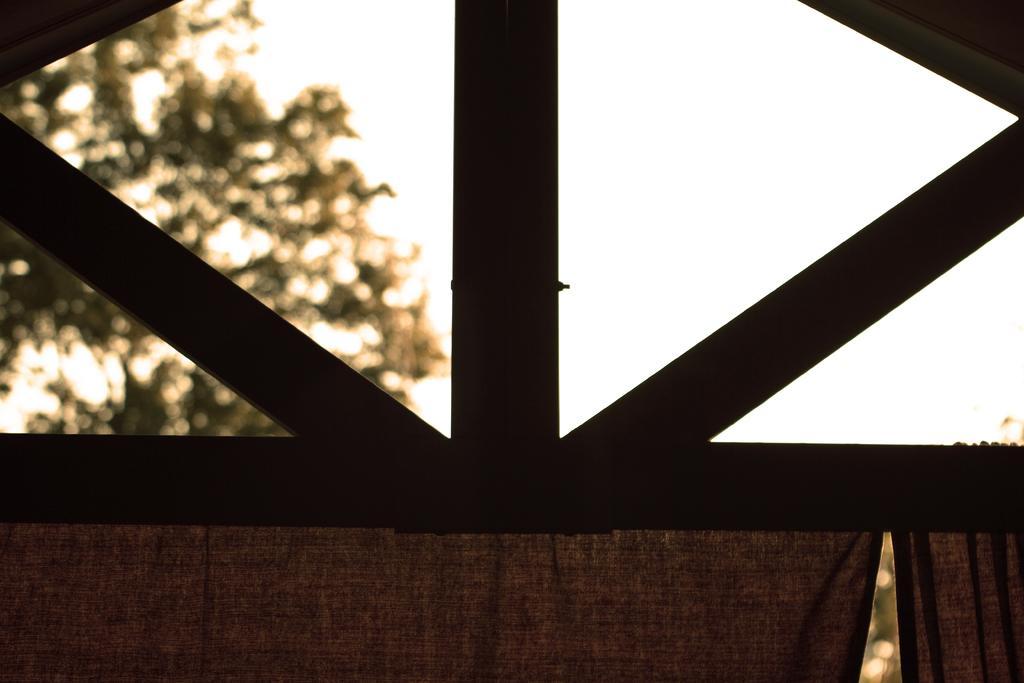How would you summarize this image in a sentence or two? Here in this picture in the front we can see a ventilation window present and below that we can see curtains present and we can see trees present in blurry manner and we can see the sky is clear. 